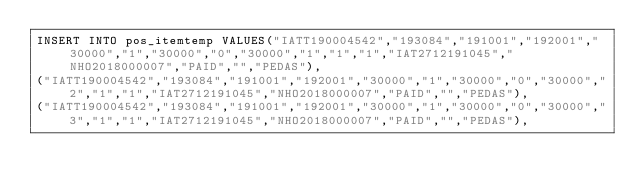Convert code to text. <code><loc_0><loc_0><loc_500><loc_500><_SQL_>INSERT INTO pos_itemtemp VALUES("IATT190004542","193084","191001","192001","30000","1","30000","0","30000","1","1","1","IAT2712191045","NHO2018000007","PAID","","PEDAS"),
("IATT190004542","193084","191001","192001","30000","1","30000","0","30000","2","1","1","IAT2712191045","NHO2018000007","PAID","","PEDAS"),
("IATT190004542","193084","191001","192001","30000","1","30000","0","30000","3","1","1","IAT2712191045","NHO2018000007","PAID","","PEDAS"),</code> 